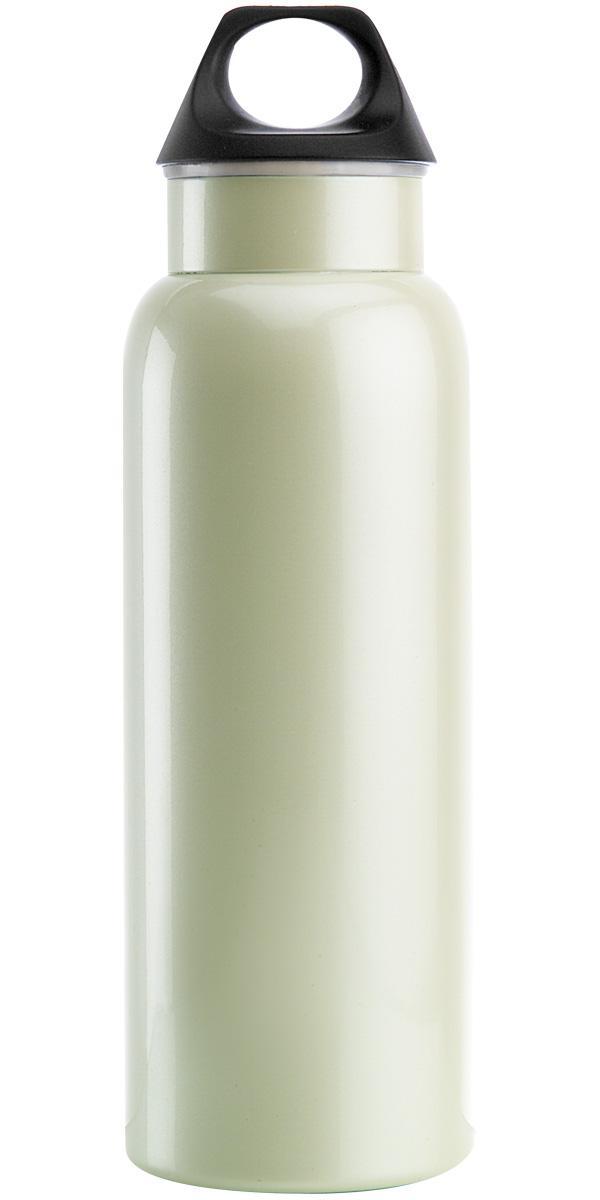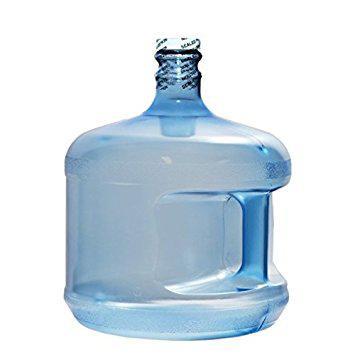The first image is the image on the left, the second image is the image on the right. For the images shown, is this caption "At least one wide blue tinted bottle with a plastic cap is shown in one image, while a second image shows a personal water bottle with detachable cap." true? Answer yes or no. Yes. The first image is the image on the left, the second image is the image on the right. Evaluate the accuracy of this statement regarding the images: "An image shows at least one stout translucent blue water jug with a lid on it.". Is it true? Answer yes or no. Yes. 